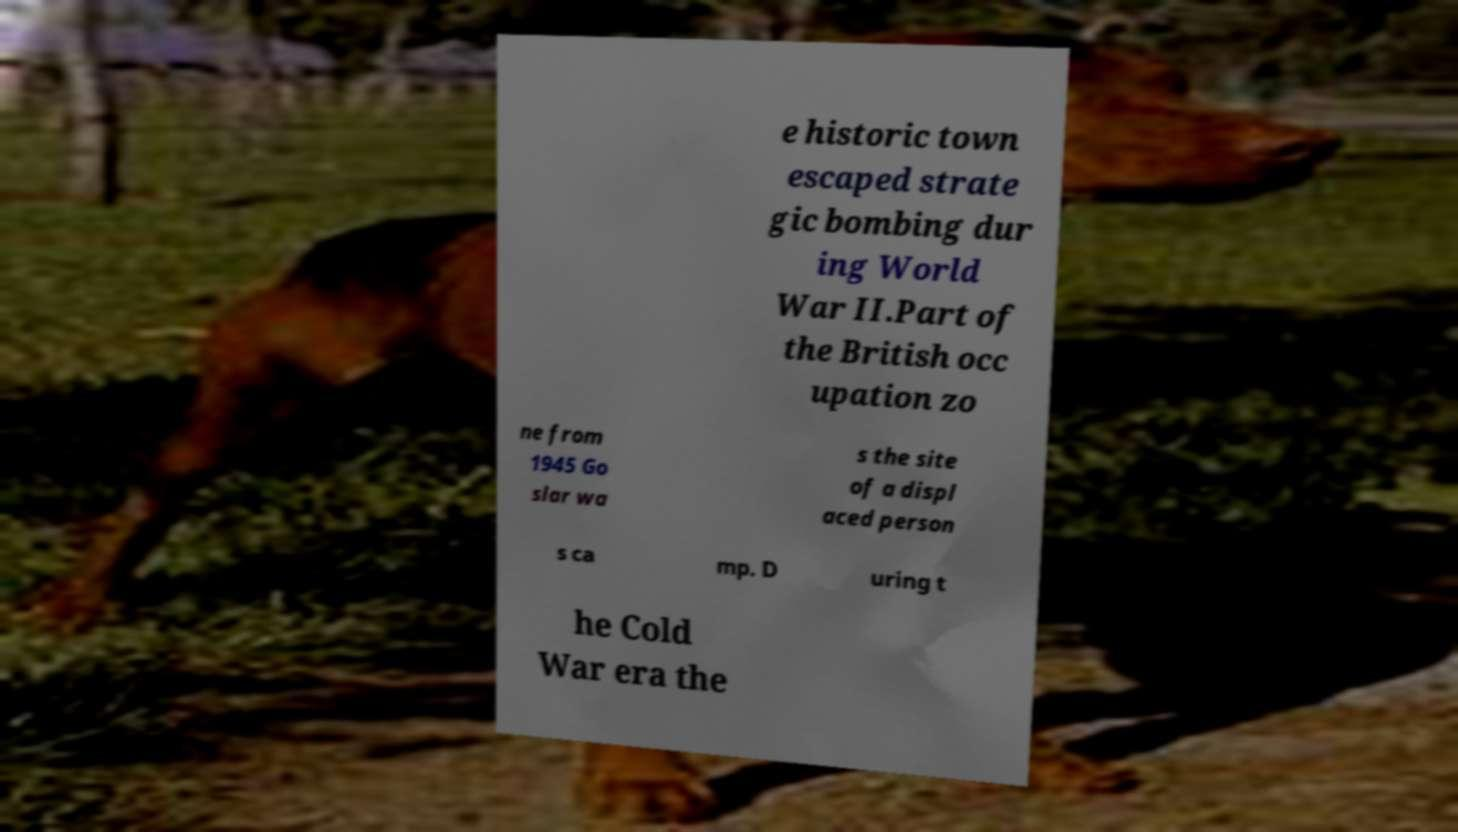For documentation purposes, I need the text within this image transcribed. Could you provide that? e historic town escaped strate gic bombing dur ing World War II.Part of the British occ upation zo ne from 1945 Go slar wa s the site of a displ aced person s ca mp. D uring t he Cold War era the 